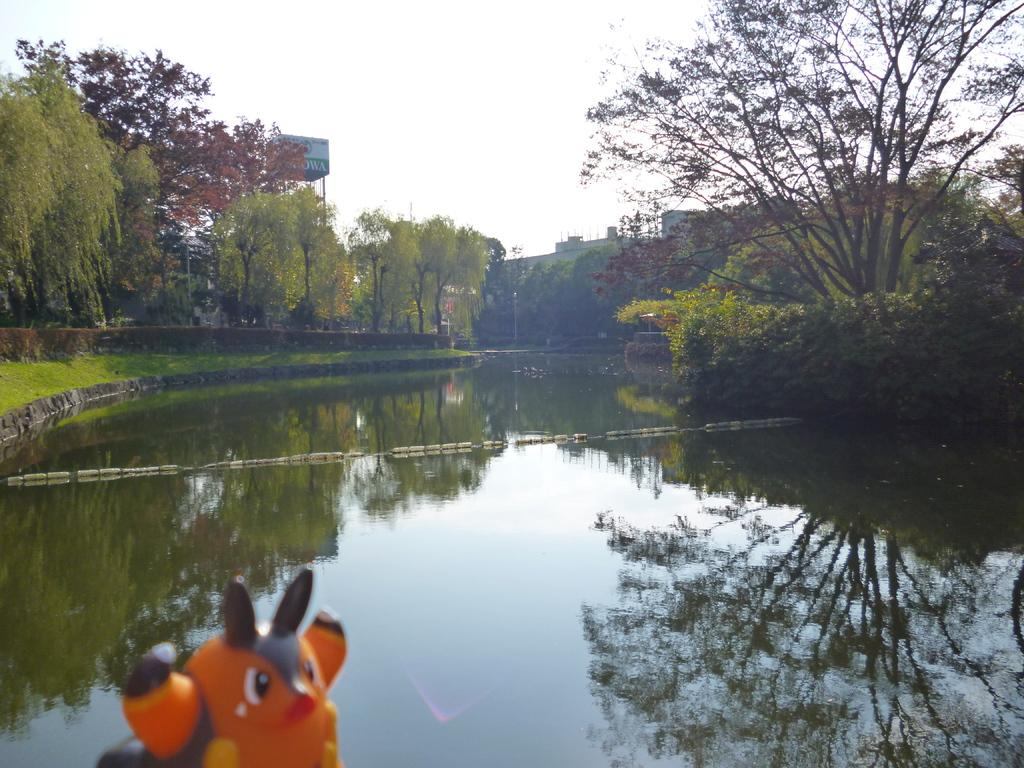What type of natural elements can be seen in the image? There are trees and water visible in the image. What type of man-made structures are present in the image? There are buildings in the image. What is the weather like in the image? The sky is cloudy in the image. What type of signage is present in the image? There is an advertisement hoarding in the image. What type of object can be seen that is not related to the natural or man-made environment? There is a toy in the image. How many snakes are slithering on the toy in the image? There are no snakes present in the image; only a toy can be seen. Can you compare the size of the hand with the trees in the image? There is no hand visible in the image, so it cannot be compared to the trees. 